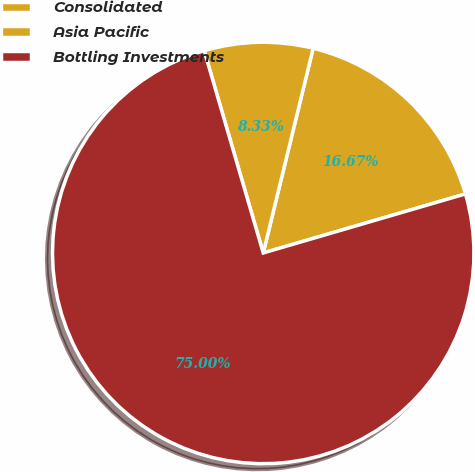Convert chart. <chart><loc_0><loc_0><loc_500><loc_500><pie_chart><fcel>Consolidated<fcel>Asia Pacific<fcel>Bottling Investments<nl><fcel>16.67%<fcel>8.33%<fcel>75.0%<nl></chart> 